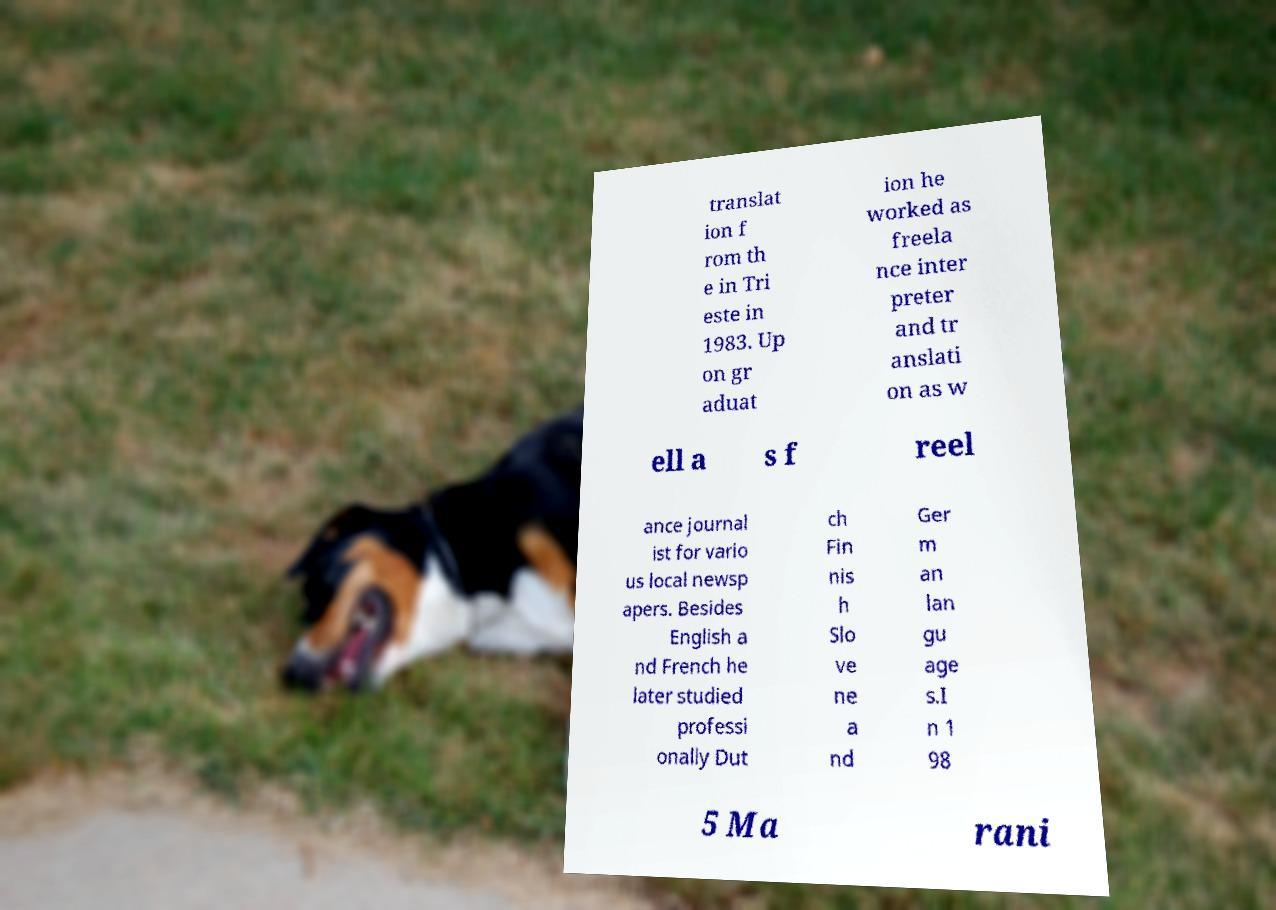For documentation purposes, I need the text within this image transcribed. Could you provide that? translat ion f rom th e in Tri este in 1983. Up on gr aduat ion he worked as freela nce inter preter and tr anslati on as w ell a s f reel ance journal ist for vario us local newsp apers. Besides English a nd French he later studied professi onally Dut ch Fin nis h Slo ve ne a nd Ger m an lan gu age s.I n 1 98 5 Ma rani 